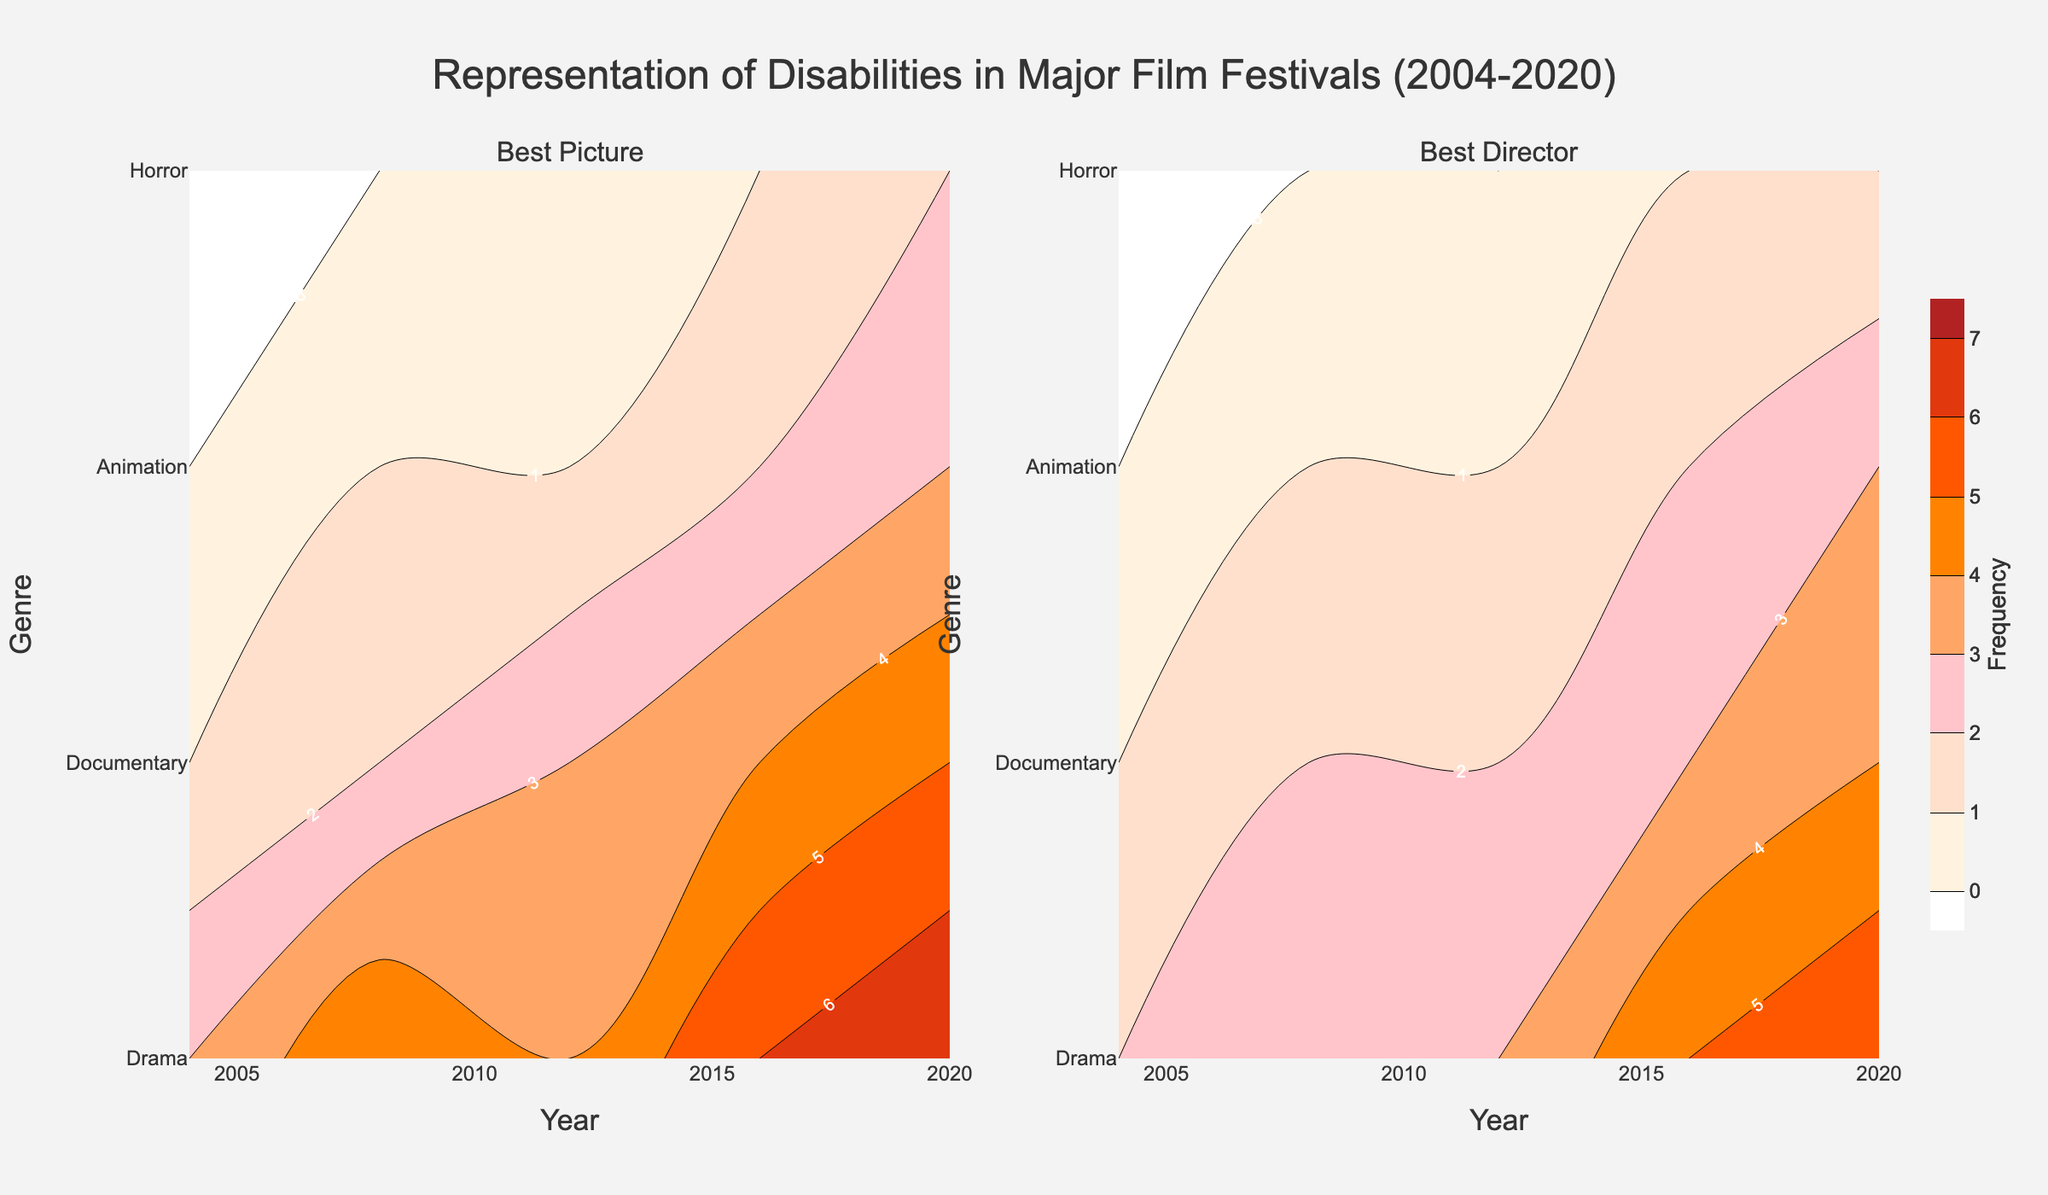How many genres are represented in the plot? Count the distinct genres displayed on the y-axis of the plot.
Answer: 4 What is the title of the plot? Read the main title displayed at the top of the plot.
Answer: Representation of Disabilities in Major Film Festivals (2004-2020) Which genre has the highest frequency in the "Best Picture" category in 2020? Observe the "Best Picture" subplot for the year 2020 and identify the highest contour value within that year for all genres.
Answer: Drama Compare the representation of disabilities in the genre "Animation" between the years 2004 and 2020 in the "Best Director" category. What is the difference in frequency? Locate the "Best Director" subplot, then find the frequency for Animation in the years 2004 and 2020, and compute the difference (2020 frequency - 2004 frequency).
Answer: 3 Which award category has an overall higher representation of disabilities across genres and years, "Best Picture" or "Best Director"? Visually compare the density and heights of contours across both subplots to assess which category generally has higher frequencies.
Answer: Best Picture What is the general trend in the representation of disabilities in the "Documentary" genre for "Best Director" over the years 2004 to 2020? Follow the contour line corresponding to the Documentary genre in the "Best Director" subplot and observe the frequency values from 2004 to 2020 to identify the trend.
Answer: Increasing How does the frequency for "Horror" genre in "Best Picture" in 2016 compare to its frequency in 2012? Check the frequency values for the "Horror" genre in the "Best Picture" subplot for the years 2012 and 2016 and compare them.
Answer: The same (both are 1) Which genre shows the highest increase in representation from 2012 to 2020 in the "Best Director" category? Evaluate the frequency values for all genres in the "Best Director" subplot for the years 2012 and 2020, and find the genre with the highest increase.
Answer: Drama In which award category does the genre "Documentary" show the smallest frequency increase between the years 2004 and 2020? Compare the increase in frequency for the Documentary genre between 2004 and 2020 in both "Best Picture" and "Best Director" subplots, and identify the smaller increase.
Answer: Best Director How did the frequency of the "Animation" genre in the "Best Picture" category change from 2008 to 2020? Examine the contour values for the "Animation" genre in the "Best Picture" subplot between the years 2008 and 2020 and note the changes.
Answer: Increased by 2 